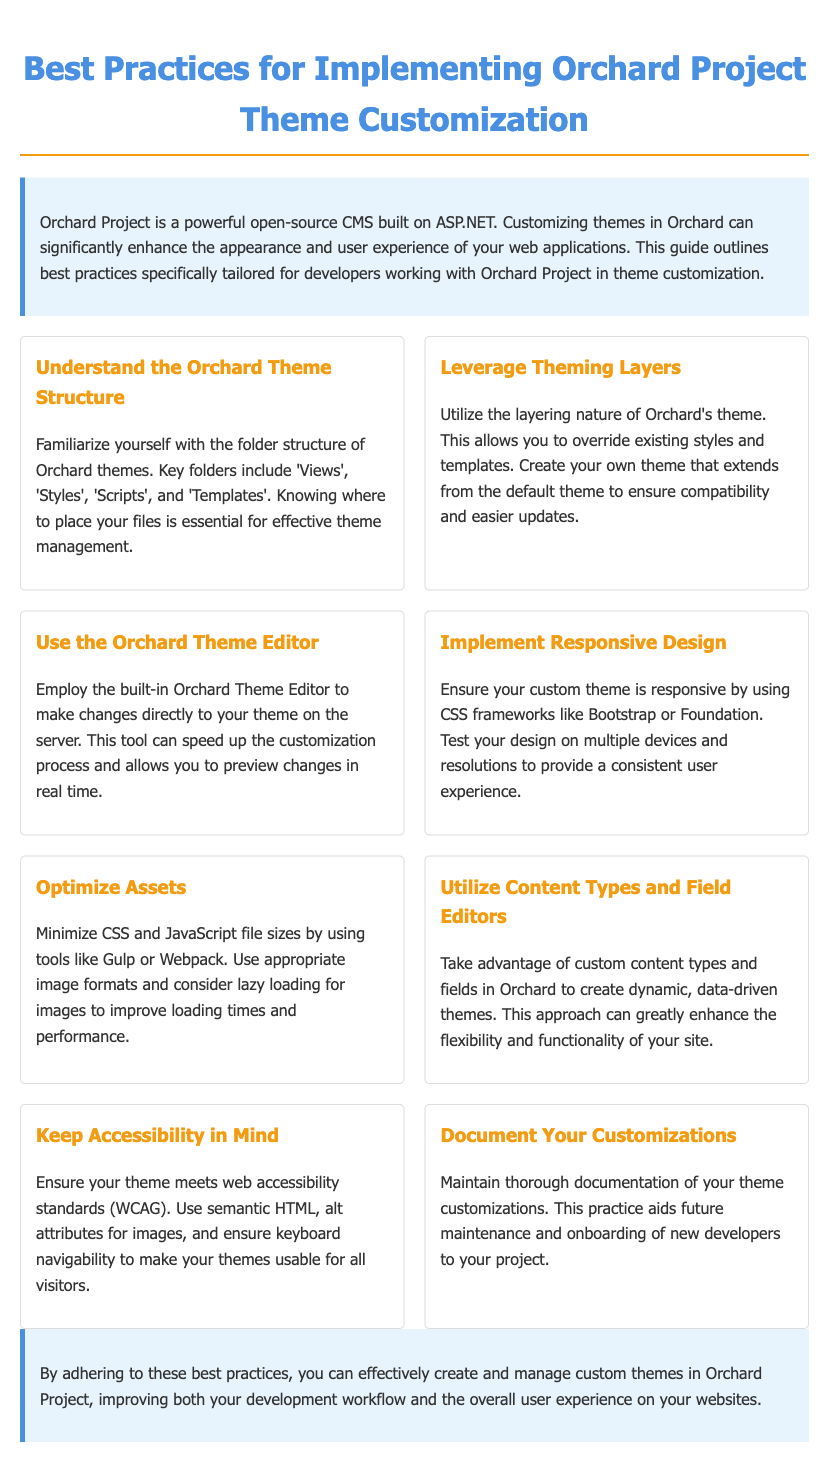What is the title of the document? The title of the document is found in the title tag of the HTML, which is "Best Practices for Implementing Orchard Project Theme Customization."
Answer: Best Practices for Implementing Orchard Project Theme Customization How many best practices are listed in the document? The number of best practices can be counted in the section that lists them, which shows a total of eight practices.
Answer: 8 What is the primary color used in the document's styling? The primary color is defined in the CSS under the root variable for primary color, which is represented as #4a90e2.
Answer: #4a90e2 Which tool is recommended for making real-time changes to themes? The document mentions the "Orchard Theme Editor" as the tool for making changes directly to the theme on the server.
Answer: Orchard Theme Editor What aspect should you ensure your custom theme meets according to best practices? The document emphasizes that your custom theme should meet web accessibility standards, specifically WCAG.
Answer: web accessibility standards Which CSS frameworks are suggested for implementing responsive design? The document recommends using CSS frameworks like "Bootstrap or Foundation" to achieve responsive design in themes.
Answer: Bootstrap or Foundation What is the purpose of documenting customizations according to the document? The document states that maintaining documentation helps with "future maintenance and onboarding of new developers" to the project.
Answer: future maintenance and onboarding of new developers Which practice involves optimizing loading times? The practice focused on improving loading times discusses "Optimizing Assets" by minimizing file sizes and considering lazy loading for images.
Answer: Optimize Assets 